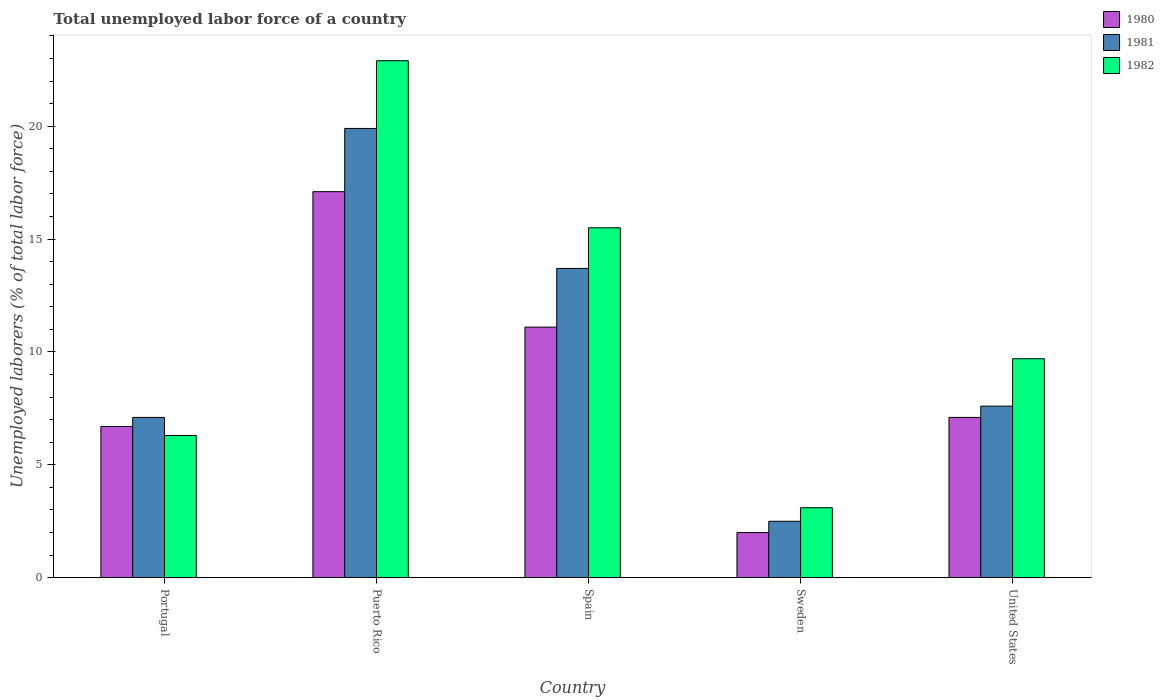Are the number of bars per tick equal to the number of legend labels?
Keep it short and to the point. Yes. How many bars are there on the 5th tick from the left?
Keep it short and to the point. 3. What is the label of the 1st group of bars from the left?
Offer a very short reply. Portugal. What is the total unemployed labor force in 1980 in Portugal?
Your answer should be compact. 6.7. Across all countries, what is the maximum total unemployed labor force in 1982?
Provide a succinct answer. 22.9. Across all countries, what is the minimum total unemployed labor force in 1981?
Offer a terse response. 2.5. In which country was the total unemployed labor force in 1981 maximum?
Provide a succinct answer. Puerto Rico. What is the total total unemployed labor force in 1981 in the graph?
Offer a terse response. 50.8. What is the difference between the total unemployed labor force in 1981 in Puerto Rico and that in United States?
Provide a succinct answer. 12.3. What is the difference between the total unemployed labor force in 1980 in Sweden and the total unemployed labor force in 1982 in United States?
Provide a short and direct response. -7.7. What is the average total unemployed labor force in 1980 per country?
Your response must be concise. 8.8. What is the difference between the total unemployed labor force of/in 1980 and total unemployed labor force of/in 1981 in Portugal?
Provide a short and direct response. -0.4. In how many countries, is the total unemployed labor force in 1981 greater than 21 %?
Make the answer very short. 0. What is the ratio of the total unemployed labor force in 1981 in Puerto Rico to that in Sweden?
Keep it short and to the point. 7.96. Is the total unemployed labor force in 1981 in Portugal less than that in United States?
Your answer should be very brief. Yes. Is the difference between the total unemployed labor force in 1980 in Portugal and Puerto Rico greater than the difference between the total unemployed labor force in 1981 in Portugal and Puerto Rico?
Your answer should be very brief. Yes. What is the difference between the highest and the second highest total unemployed labor force in 1981?
Ensure brevity in your answer.  6.2. What is the difference between the highest and the lowest total unemployed labor force in 1980?
Provide a succinct answer. 15.1. Is the sum of the total unemployed labor force in 1981 in Puerto Rico and United States greater than the maximum total unemployed labor force in 1982 across all countries?
Give a very brief answer. Yes. Are all the bars in the graph horizontal?
Keep it short and to the point. No. Does the graph contain any zero values?
Keep it short and to the point. No. Does the graph contain grids?
Offer a terse response. No. How many legend labels are there?
Ensure brevity in your answer.  3. What is the title of the graph?
Offer a very short reply. Total unemployed labor force of a country. What is the label or title of the X-axis?
Make the answer very short. Country. What is the label or title of the Y-axis?
Ensure brevity in your answer.  Unemployed laborers (% of total labor force). What is the Unemployed laborers (% of total labor force) of 1980 in Portugal?
Provide a short and direct response. 6.7. What is the Unemployed laborers (% of total labor force) of 1981 in Portugal?
Provide a short and direct response. 7.1. What is the Unemployed laborers (% of total labor force) in 1982 in Portugal?
Offer a very short reply. 6.3. What is the Unemployed laborers (% of total labor force) of 1980 in Puerto Rico?
Ensure brevity in your answer.  17.1. What is the Unemployed laborers (% of total labor force) of 1981 in Puerto Rico?
Your answer should be very brief. 19.9. What is the Unemployed laborers (% of total labor force) in 1982 in Puerto Rico?
Your answer should be compact. 22.9. What is the Unemployed laborers (% of total labor force) in 1980 in Spain?
Keep it short and to the point. 11.1. What is the Unemployed laborers (% of total labor force) of 1981 in Spain?
Provide a succinct answer. 13.7. What is the Unemployed laborers (% of total labor force) in 1982 in Spain?
Keep it short and to the point. 15.5. What is the Unemployed laborers (% of total labor force) of 1980 in Sweden?
Keep it short and to the point. 2. What is the Unemployed laborers (% of total labor force) in 1982 in Sweden?
Give a very brief answer. 3.1. What is the Unemployed laborers (% of total labor force) in 1980 in United States?
Give a very brief answer. 7.1. What is the Unemployed laborers (% of total labor force) in 1981 in United States?
Keep it short and to the point. 7.6. What is the Unemployed laborers (% of total labor force) of 1982 in United States?
Offer a terse response. 9.7. Across all countries, what is the maximum Unemployed laborers (% of total labor force) in 1980?
Your response must be concise. 17.1. Across all countries, what is the maximum Unemployed laborers (% of total labor force) in 1981?
Your answer should be compact. 19.9. Across all countries, what is the maximum Unemployed laborers (% of total labor force) in 1982?
Offer a terse response. 22.9. Across all countries, what is the minimum Unemployed laborers (% of total labor force) in 1980?
Provide a short and direct response. 2. Across all countries, what is the minimum Unemployed laborers (% of total labor force) of 1982?
Your answer should be very brief. 3.1. What is the total Unemployed laborers (% of total labor force) of 1981 in the graph?
Give a very brief answer. 50.8. What is the total Unemployed laborers (% of total labor force) in 1982 in the graph?
Offer a terse response. 57.5. What is the difference between the Unemployed laborers (% of total labor force) of 1982 in Portugal and that in Puerto Rico?
Give a very brief answer. -16.6. What is the difference between the Unemployed laborers (% of total labor force) in 1980 in Portugal and that in Spain?
Ensure brevity in your answer.  -4.4. What is the difference between the Unemployed laborers (% of total labor force) of 1981 in Portugal and that in Spain?
Ensure brevity in your answer.  -6.6. What is the difference between the Unemployed laborers (% of total labor force) in 1982 in Portugal and that in Spain?
Give a very brief answer. -9.2. What is the difference between the Unemployed laborers (% of total labor force) of 1980 in Portugal and that in Sweden?
Provide a succinct answer. 4.7. What is the difference between the Unemployed laborers (% of total labor force) in 1982 in Portugal and that in Sweden?
Your answer should be compact. 3.2. What is the difference between the Unemployed laborers (% of total labor force) in 1981 in Portugal and that in United States?
Provide a succinct answer. -0.5. What is the difference between the Unemployed laborers (% of total labor force) of 1982 in Portugal and that in United States?
Provide a short and direct response. -3.4. What is the difference between the Unemployed laborers (% of total labor force) in 1981 in Puerto Rico and that in Sweden?
Your answer should be very brief. 17.4. What is the difference between the Unemployed laborers (% of total labor force) of 1982 in Puerto Rico and that in Sweden?
Keep it short and to the point. 19.8. What is the difference between the Unemployed laborers (% of total labor force) in 1981 in Puerto Rico and that in United States?
Give a very brief answer. 12.3. What is the difference between the Unemployed laborers (% of total labor force) in 1981 in Spain and that in Sweden?
Give a very brief answer. 11.2. What is the difference between the Unemployed laborers (% of total labor force) in 1982 in Spain and that in Sweden?
Your answer should be compact. 12.4. What is the difference between the Unemployed laborers (% of total labor force) in 1980 in Spain and that in United States?
Keep it short and to the point. 4. What is the difference between the Unemployed laborers (% of total labor force) in 1981 in Spain and that in United States?
Keep it short and to the point. 6.1. What is the difference between the Unemployed laborers (% of total labor force) of 1982 in Spain and that in United States?
Your answer should be very brief. 5.8. What is the difference between the Unemployed laborers (% of total labor force) of 1981 in Sweden and that in United States?
Keep it short and to the point. -5.1. What is the difference between the Unemployed laborers (% of total labor force) in 1982 in Sweden and that in United States?
Offer a very short reply. -6.6. What is the difference between the Unemployed laborers (% of total labor force) in 1980 in Portugal and the Unemployed laborers (% of total labor force) in 1982 in Puerto Rico?
Provide a succinct answer. -16.2. What is the difference between the Unemployed laborers (% of total labor force) in 1981 in Portugal and the Unemployed laborers (% of total labor force) in 1982 in Puerto Rico?
Your answer should be very brief. -15.8. What is the difference between the Unemployed laborers (% of total labor force) of 1980 in Portugal and the Unemployed laborers (% of total labor force) of 1981 in Sweden?
Give a very brief answer. 4.2. What is the difference between the Unemployed laborers (% of total labor force) in 1980 in Portugal and the Unemployed laborers (% of total labor force) in 1982 in Sweden?
Offer a terse response. 3.6. What is the difference between the Unemployed laborers (% of total labor force) of 1981 in Portugal and the Unemployed laborers (% of total labor force) of 1982 in Sweden?
Offer a terse response. 4. What is the difference between the Unemployed laborers (% of total labor force) in 1980 in Portugal and the Unemployed laborers (% of total labor force) in 1981 in United States?
Your response must be concise. -0.9. What is the difference between the Unemployed laborers (% of total labor force) of 1980 in Portugal and the Unemployed laborers (% of total labor force) of 1982 in United States?
Your answer should be very brief. -3. What is the difference between the Unemployed laborers (% of total labor force) in 1981 in Portugal and the Unemployed laborers (% of total labor force) in 1982 in United States?
Provide a succinct answer. -2.6. What is the difference between the Unemployed laborers (% of total labor force) of 1981 in Puerto Rico and the Unemployed laborers (% of total labor force) of 1982 in Spain?
Your answer should be compact. 4.4. What is the difference between the Unemployed laborers (% of total labor force) in 1980 in Puerto Rico and the Unemployed laborers (% of total labor force) in 1981 in Sweden?
Keep it short and to the point. 14.6. What is the difference between the Unemployed laborers (% of total labor force) in 1980 in Puerto Rico and the Unemployed laborers (% of total labor force) in 1982 in Sweden?
Offer a terse response. 14. What is the difference between the Unemployed laborers (% of total labor force) in 1980 in Puerto Rico and the Unemployed laborers (% of total labor force) in 1982 in United States?
Your answer should be compact. 7.4. What is the difference between the Unemployed laborers (% of total labor force) in 1980 in Spain and the Unemployed laborers (% of total labor force) in 1981 in Sweden?
Keep it short and to the point. 8.6. What is the difference between the Unemployed laborers (% of total labor force) of 1981 in Spain and the Unemployed laborers (% of total labor force) of 1982 in Sweden?
Give a very brief answer. 10.6. What is the difference between the Unemployed laborers (% of total labor force) of 1980 in Spain and the Unemployed laborers (% of total labor force) of 1982 in United States?
Provide a short and direct response. 1.4. What is the difference between the Unemployed laborers (% of total labor force) of 1980 in Sweden and the Unemployed laborers (% of total labor force) of 1981 in United States?
Offer a terse response. -5.6. What is the difference between the Unemployed laborers (% of total labor force) in 1980 in Sweden and the Unemployed laborers (% of total labor force) in 1982 in United States?
Your response must be concise. -7.7. What is the difference between the Unemployed laborers (% of total labor force) in 1981 in Sweden and the Unemployed laborers (% of total labor force) in 1982 in United States?
Offer a very short reply. -7.2. What is the average Unemployed laborers (% of total labor force) in 1981 per country?
Ensure brevity in your answer.  10.16. What is the difference between the Unemployed laborers (% of total labor force) of 1980 and Unemployed laborers (% of total labor force) of 1981 in Puerto Rico?
Give a very brief answer. -2.8. What is the difference between the Unemployed laborers (% of total labor force) in 1981 and Unemployed laborers (% of total labor force) in 1982 in Puerto Rico?
Your answer should be compact. -3. What is the difference between the Unemployed laborers (% of total labor force) of 1980 and Unemployed laborers (% of total labor force) of 1982 in Spain?
Provide a succinct answer. -4.4. What is the difference between the Unemployed laborers (% of total labor force) of 1981 and Unemployed laborers (% of total labor force) of 1982 in Spain?
Offer a very short reply. -1.8. What is the difference between the Unemployed laborers (% of total labor force) in 1980 and Unemployed laborers (% of total labor force) in 1981 in Sweden?
Give a very brief answer. -0.5. What is the difference between the Unemployed laborers (% of total labor force) in 1980 and Unemployed laborers (% of total labor force) in 1981 in United States?
Your response must be concise. -0.5. What is the difference between the Unemployed laborers (% of total labor force) in 1980 and Unemployed laborers (% of total labor force) in 1982 in United States?
Offer a terse response. -2.6. What is the ratio of the Unemployed laborers (% of total labor force) of 1980 in Portugal to that in Puerto Rico?
Offer a terse response. 0.39. What is the ratio of the Unemployed laborers (% of total labor force) in 1981 in Portugal to that in Puerto Rico?
Your response must be concise. 0.36. What is the ratio of the Unemployed laborers (% of total labor force) of 1982 in Portugal to that in Puerto Rico?
Keep it short and to the point. 0.28. What is the ratio of the Unemployed laborers (% of total labor force) in 1980 in Portugal to that in Spain?
Your answer should be very brief. 0.6. What is the ratio of the Unemployed laborers (% of total labor force) of 1981 in Portugal to that in Spain?
Offer a terse response. 0.52. What is the ratio of the Unemployed laborers (% of total labor force) of 1982 in Portugal to that in Spain?
Make the answer very short. 0.41. What is the ratio of the Unemployed laborers (% of total labor force) in 1980 in Portugal to that in Sweden?
Your answer should be very brief. 3.35. What is the ratio of the Unemployed laborers (% of total labor force) of 1981 in Portugal to that in Sweden?
Ensure brevity in your answer.  2.84. What is the ratio of the Unemployed laborers (% of total labor force) in 1982 in Portugal to that in Sweden?
Your answer should be very brief. 2.03. What is the ratio of the Unemployed laborers (% of total labor force) in 1980 in Portugal to that in United States?
Your response must be concise. 0.94. What is the ratio of the Unemployed laborers (% of total labor force) in 1981 in Portugal to that in United States?
Give a very brief answer. 0.93. What is the ratio of the Unemployed laborers (% of total labor force) of 1982 in Portugal to that in United States?
Ensure brevity in your answer.  0.65. What is the ratio of the Unemployed laborers (% of total labor force) of 1980 in Puerto Rico to that in Spain?
Make the answer very short. 1.54. What is the ratio of the Unemployed laborers (% of total labor force) in 1981 in Puerto Rico to that in Spain?
Your response must be concise. 1.45. What is the ratio of the Unemployed laborers (% of total labor force) in 1982 in Puerto Rico to that in Spain?
Give a very brief answer. 1.48. What is the ratio of the Unemployed laborers (% of total labor force) in 1980 in Puerto Rico to that in Sweden?
Your answer should be very brief. 8.55. What is the ratio of the Unemployed laborers (% of total labor force) in 1981 in Puerto Rico to that in Sweden?
Give a very brief answer. 7.96. What is the ratio of the Unemployed laborers (% of total labor force) in 1982 in Puerto Rico to that in Sweden?
Your answer should be very brief. 7.39. What is the ratio of the Unemployed laborers (% of total labor force) of 1980 in Puerto Rico to that in United States?
Give a very brief answer. 2.41. What is the ratio of the Unemployed laborers (% of total labor force) of 1981 in Puerto Rico to that in United States?
Ensure brevity in your answer.  2.62. What is the ratio of the Unemployed laborers (% of total labor force) of 1982 in Puerto Rico to that in United States?
Your answer should be compact. 2.36. What is the ratio of the Unemployed laborers (% of total labor force) in 1980 in Spain to that in Sweden?
Give a very brief answer. 5.55. What is the ratio of the Unemployed laborers (% of total labor force) of 1981 in Spain to that in Sweden?
Make the answer very short. 5.48. What is the ratio of the Unemployed laborers (% of total labor force) of 1980 in Spain to that in United States?
Give a very brief answer. 1.56. What is the ratio of the Unemployed laborers (% of total labor force) of 1981 in Spain to that in United States?
Make the answer very short. 1.8. What is the ratio of the Unemployed laborers (% of total labor force) in 1982 in Spain to that in United States?
Make the answer very short. 1.6. What is the ratio of the Unemployed laborers (% of total labor force) in 1980 in Sweden to that in United States?
Offer a terse response. 0.28. What is the ratio of the Unemployed laborers (% of total labor force) of 1981 in Sweden to that in United States?
Ensure brevity in your answer.  0.33. What is the ratio of the Unemployed laborers (% of total labor force) in 1982 in Sweden to that in United States?
Your response must be concise. 0.32. What is the difference between the highest and the second highest Unemployed laborers (% of total labor force) in 1980?
Ensure brevity in your answer.  6. What is the difference between the highest and the second highest Unemployed laborers (% of total labor force) in 1982?
Give a very brief answer. 7.4. What is the difference between the highest and the lowest Unemployed laborers (% of total labor force) in 1980?
Your response must be concise. 15.1. What is the difference between the highest and the lowest Unemployed laborers (% of total labor force) in 1982?
Your response must be concise. 19.8. 